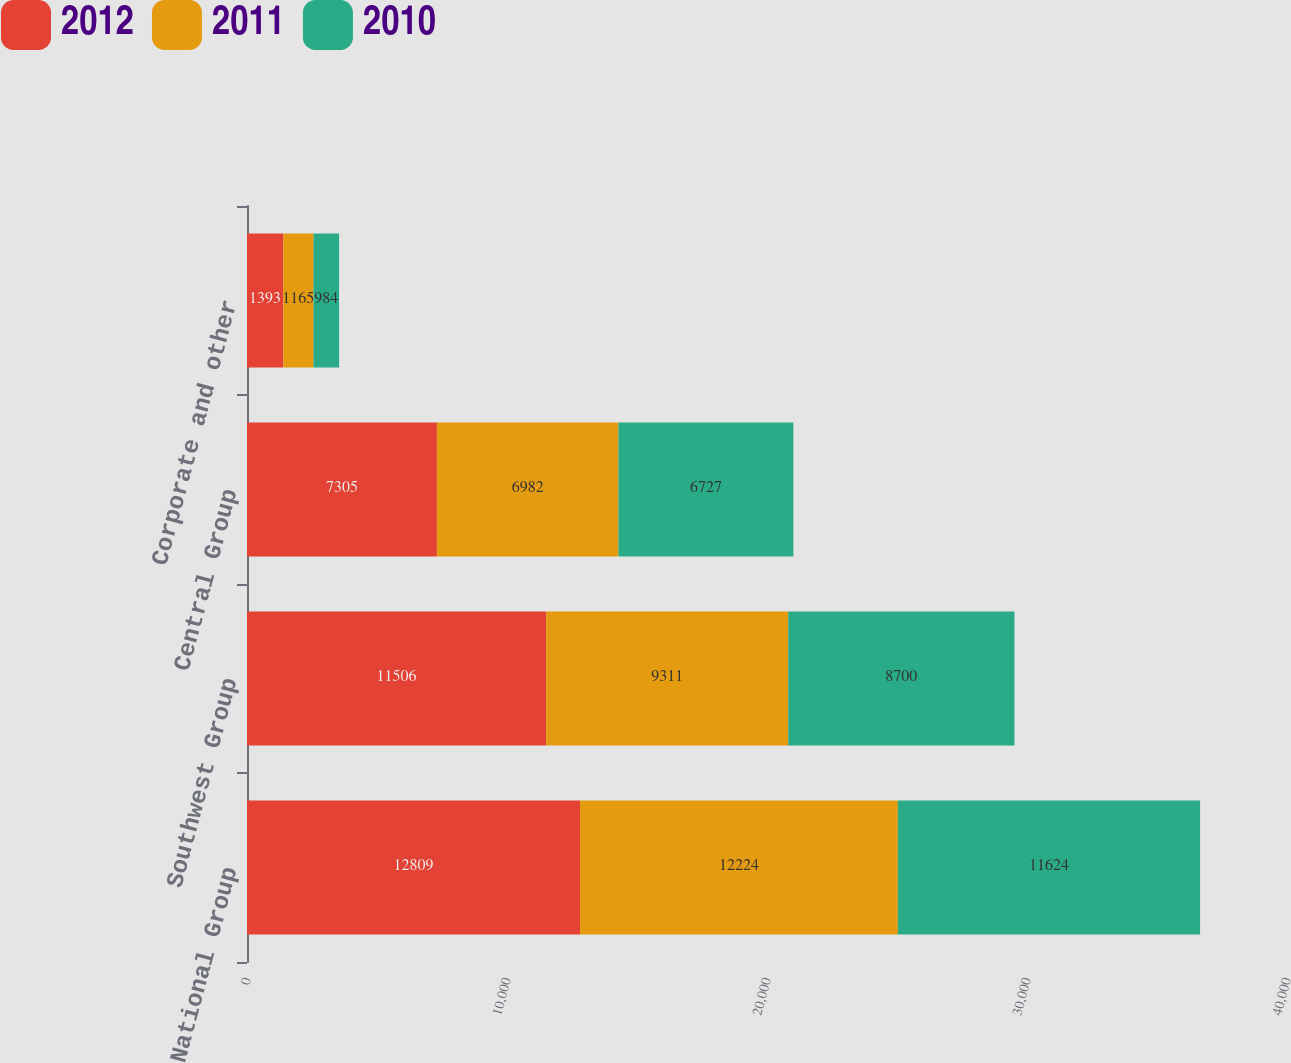Convert chart. <chart><loc_0><loc_0><loc_500><loc_500><stacked_bar_chart><ecel><fcel>National Group<fcel>Southwest Group<fcel>Central Group<fcel>Corporate and other<nl><fcel>2012<fcel>12809<fcel>11506<fcel>7305<fcel>1393<nl><fcel>2011<fcel>12224<fcel>9311<fcel>6982<fcel>1165<nl><fcel>2010<fcel>11624<fcel>8700<fcel>6727<fcel>984<nl></chart> 